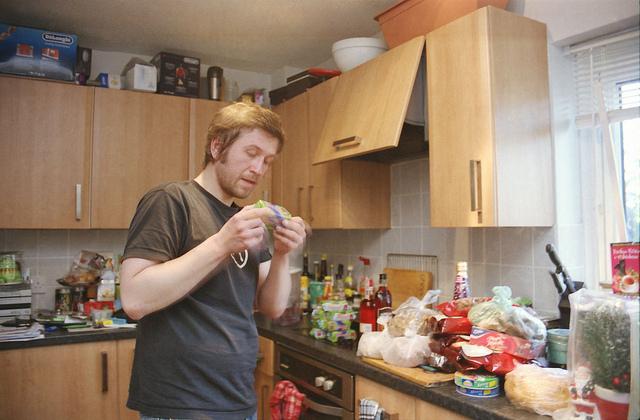Is the kitchen neat?
Short answer required. No. Are there photos in the background?
Give a very brief answer. No. What type of fruit is the person holding?
Quick response, please. Apple. Is this a man or a woman?
Concise answer only. Man. What is on the counter?
Answer briefly. Food. What room is this?
Concise answer only. Kitchen. 